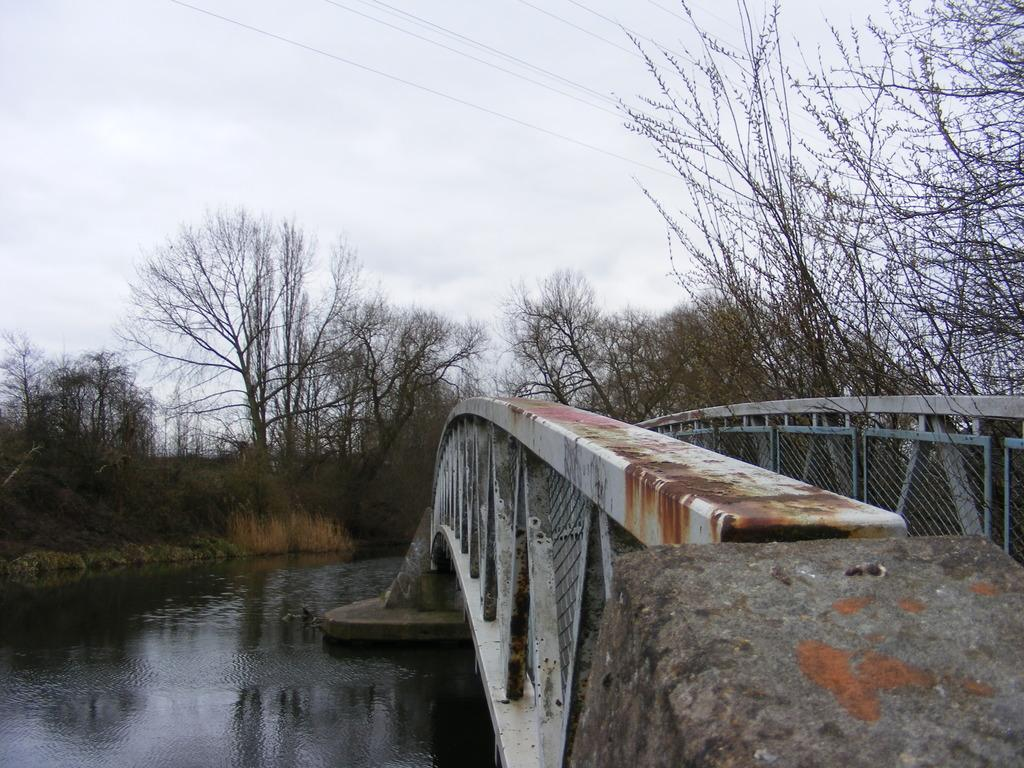What type of water feature is located on the left side of the image? There is a pond on the left side of the image. What type of structure is on the right side of the image? There is an iron bridge on the right side of the image. What type of vegetation can be seen in the image? There are trees visible in the image. What is the condition of the sky in the image? The sky is cloudy in the image. Where is the drain located in the image? There is no drain present in the image. Can you describe the father's interaction with the trees in the image? There is no father present in the image, and therefore no interaction with the trees can be observed. 